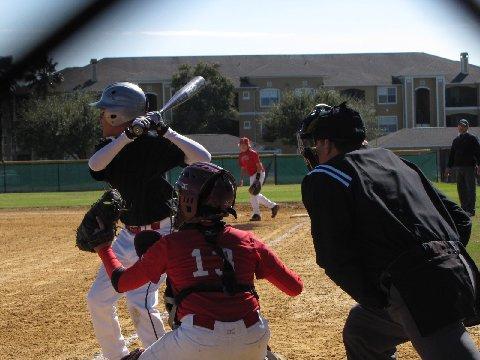How many people are in the photo?
Give a very brief answer. 3. How many baseball gloves are there?
Give a very brief answer. 1. 